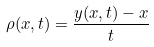<formula> <loc_0><loc_0><loc_500><loc_500>\rho ( x , t ) = \frac { y ( x , t ) - x } { t }</formula> 